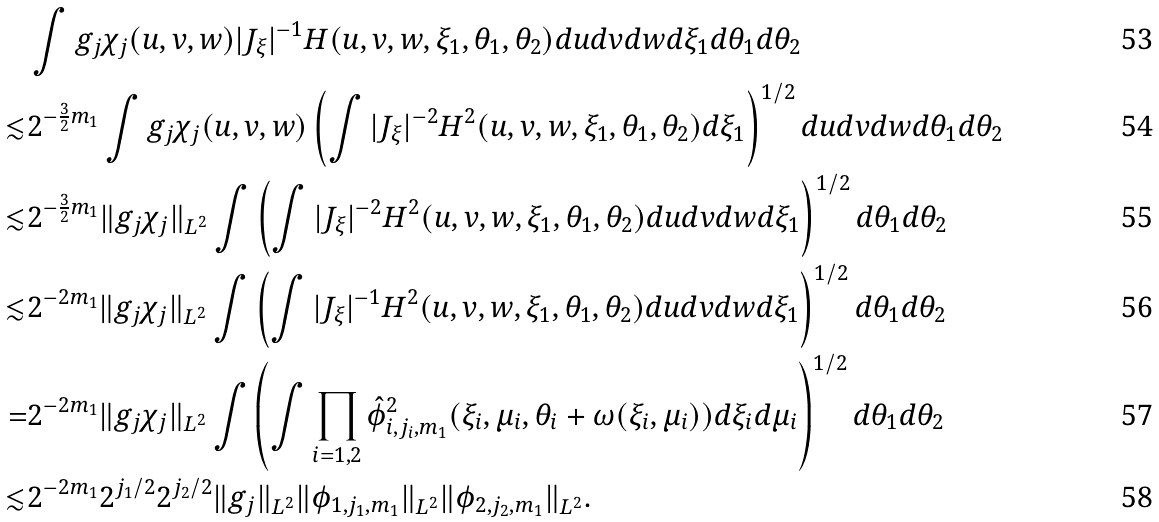<formula> <loc_0><loc_0><loc_500><loc_500>& \int g _ { j } \chi _ { j } ( u , v , w ) | J _ { \xi } | ^ { - 1 } H ( u , v , w , \xi _ { 1 } , \theta _ { 1 } , \theta _ { 2 } ) d u d v d w d \xi _ { 1 } d \theta _ { 1 } d \theta _ { 2 } \\ \lesssim & 2 ^ { - \frac { 3 } { 2 } m _ { 1 } } \int g _ { j } \chi _ { j } ( u , v , w ) \left ( \int | J _ { \xi } | ^ { - 2 } H ^ { 2 } ( u , v , w , \xi _ { 1 } , \theta _ { 1 } , \theta _ { 2 } ) d \xi _ { 1 } \right ) ^ { 1 / 2 } d u d v d w d \theta _ { 1 } d \theta _ { 2 } \\ \lesssim & 2 ^ { - \frac { 3 } { 2 } m _ { 1 } } \| g _ { j } \chi _ { j } \| _ { L ^ { 2 } } \int \left ( \int | J _ { \xi } | ^ { - 2 } H ^ { 2 } ( u , v , w , \xi _ { 1 } , \theta _ { 1 } , \theta _ { 2 } ) d u d v d w d \xi _ { 1 } \right ) ^ { 1 / 2 } d \theta _ { 1 } d \theta _ { 2 } \\ \lesssim & 2 ^ { - 2 m _ { 1 } } \| g _ { j } \chi _ { j } \| _ { L ^ { 2 } } \int \left ( \int | J _ { \xi } | ^ { - 1 } H ^ { 2 } ( u , v , w , \xi _ { 1 } , \theta _ { 1 } , \theta _ { 2 } ) d u d v d w d \xi _ { 1 } \right ) ^ { 1 / 2 } d \theta _ { 1 } d \theta _ { 2 } \\ = & 2 ^ { - 2 m _ { 1 } } \| g _ { j } \chi _ { j } \| _ { L ^ { 2 } } \int \left ( \int \prod _ { i = 1 , 2 } \hat { \phi } ^ { 2 } _ { i , j _ { i } , m _ { 1 } } ( \xi _ { i } , \mu _ { i } , \theta _ { i } + \omega ( \xi _ { i } , \mu _ { i } ) ) d \xi _ { i } d \mu _ { i } \right ) ^ { 1 / 2 } d \theta _ { 1 } d \theta _ { 2 } \\ \lesssim & 2 ^ { - 2 m _ { 1 } } 2 ^ { j _ { 1 } / 2 } 2 ^ { j _ { 2 } / 2 } \| g _ { j } \| _ { L ^ { 2 } } \| \phi _ { 1 , j _ { 1 } , m _ { 1 } } \| _ { L ^ { 2 } } \| \phi _ { 2 , j _ { 2 } , m _ { 1 } } \| _ { L ^ { 2 } } .</formula> 